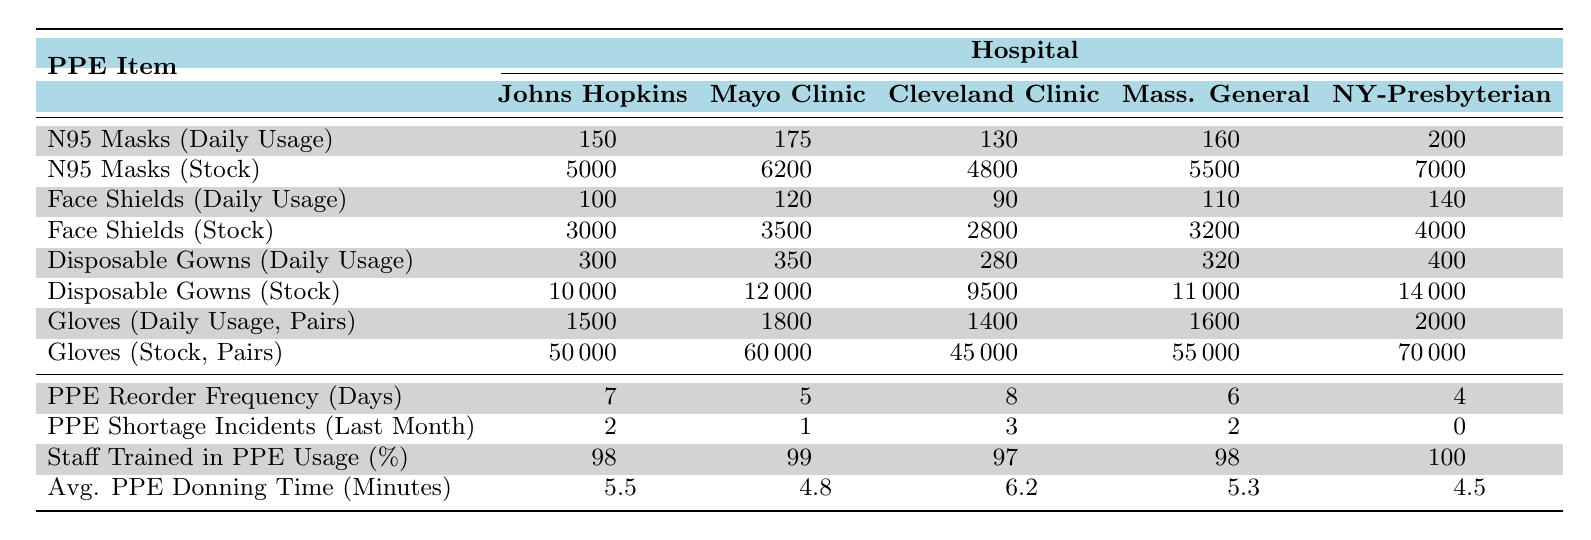What's the daily usage of N95 masks at Johns Hopkins Hospital? The table shows the daily usage of N95 masks for each hospital. Looking at the row for N95 Masks (Daily Usage), Johns Hopkins Hospital has a daily usage of 150 N95 masks.
Answer: 150 How many N95 masks are in stock at the Mayo Clinic? According to the table, the stock level for N95 masks at the Mayo Clinic is listed in the row for N95 Masks (Stock). It shows a stock level of 6200 masks.
Answer: 6200 Which hospital has the highest daily usage of gloves? To determine which hospital has the highest daily usage of gloves, we check the row for Gloves (Daily Usage, Pairs) and compare the values. New York-Presbyterian Hospital has the highest usage with 2000 pairs.
Answer: New York-Presbyterian Hospital What is the total daily usage of Face Shields across all hospitals? We look at the daily usage of Face Shields in the table, which are 100, 120, 90, 110, and 140 respectively for each hospital. Adding these amounts gives: 100 + 120 + 90 + 110 + 140 = 560.
Answer: 560 Is there any hospital that reported zero PPE shortage incidents in the last month? Referring to the row PPE Shortage Incidents (Last Month), New York-Presbyterian Hospital reported 0 incidents. So, yes, there is one hospital with no incidents.
Answer: Yes What is the average daily usage of Disposable Gowns across these hospitals? We check the daily usage of Disposable Gowns: 300, 350, 280, 320, and 400. The average is calculated by summing these values: 300 + 350 + 280 + 320 + 400 = 1650, and dividing by the number of hospitals (5): 1650 / 5 = 330.
Answer: 330 Which hospital has the shortest PPE donning time? The table shows the Average PPE Donning Time (Minutes) for each hospital. Looking at the values, New York-Presbyterian Hospital has the shortest time of 4.5 minutes.
Answer: New York-Presbyterian Hospital How many pairs of gloves are in stock at the Cleveland Clinic? According to the table, in the row for Gloves (Stock, Pairs), the stock level at Cleveland Clinic is 45000 pairs.
Answer: 45000 What is the difference in daily usage of Disposable Gowns between the Mayo Clinic and New York-Presbyterian Hospital? Checking the values for Disposable Gowns (Daily Usage), Mayo Clinic uses 350 gowns daily while New York-Presbyterian uses 400. The difference is calculated as 400 - 350 = 50 gowns.
Answer: 50 What percentage of staff at Massachusetts General Hospital are trained in PPE usage? The table indicates that 98% of the staff at Massachusetts General Hospital are trained in PPE usage as shown in the row for Staff Trained in PPE Usage (%).
Answer: 98% 